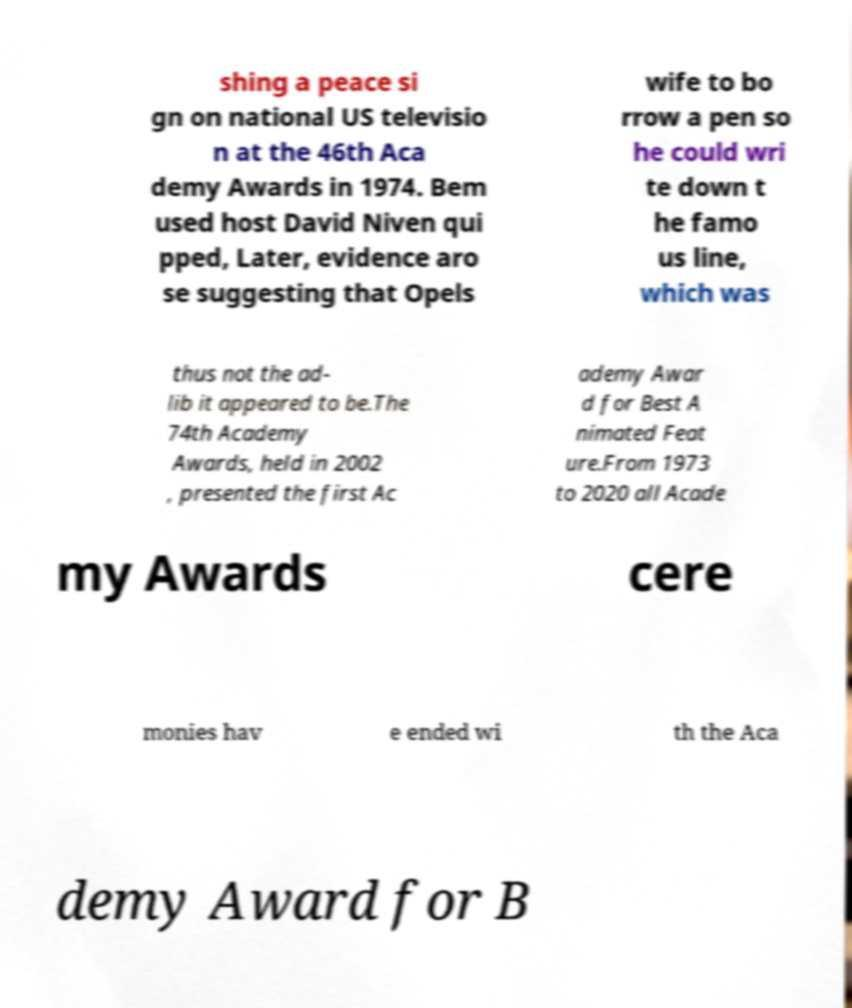For documentation purposes, I need the text within this image transcribed. Could you provide that? shing a peace si gn on national US televisio n at the 46th Aca demy Awards in 1974. Bem used host David Niven qui pped, Later, evidence aro se suggesting that Opels wife to bo rrow a pen so he could wri te down t he famo us line, which was thus not the ad- lib it appeared to be.The 74th Academy Awards, held in 2002 , presented the first Ac ademy Awar d for Best A nimated Feat ure.From 1973 to 2020 all Acade my Awards cere monies hav e ended wi th the Aca demy Award for B 